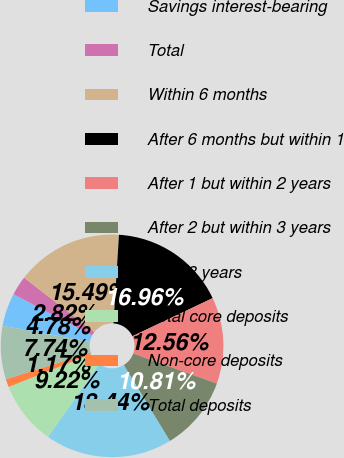Convert chart. <chart><loc_0><loc_0><loc_500><loc_500><pie_chart><fcel>Savings interest-bearing<fcel>Total<fcel>Within 6 months<fcel>After 6 months but within 1<fcel>After 1 but within 2 years<fcel>After 2 but within 3 years<fcel>After 3 years<fcel>Total core deposits<fcel>Non-core deposits<fcel>Total deposits<nl><fcel>4.78%<fcel>2.82%<fcel>15.49%<fcel>16.96%<fcel>12.56%<fcel>10.81%<fcel>18.44%<fcel>9.22%<fcel>1.17%<fcel>7.74%<nl></chart> 